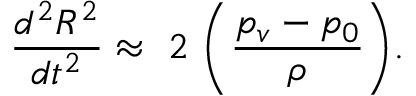Convert formula to latex. <formula><loc_0><loc_0><loc_500><loc_500>\frac { d ^ { 2 } R ^ { 2 } } { d t ^ { 2 } } \approx 2 \left ( \frac { p _ { v } - p _ { 0 } } { \rho } \right ) .</formula> 